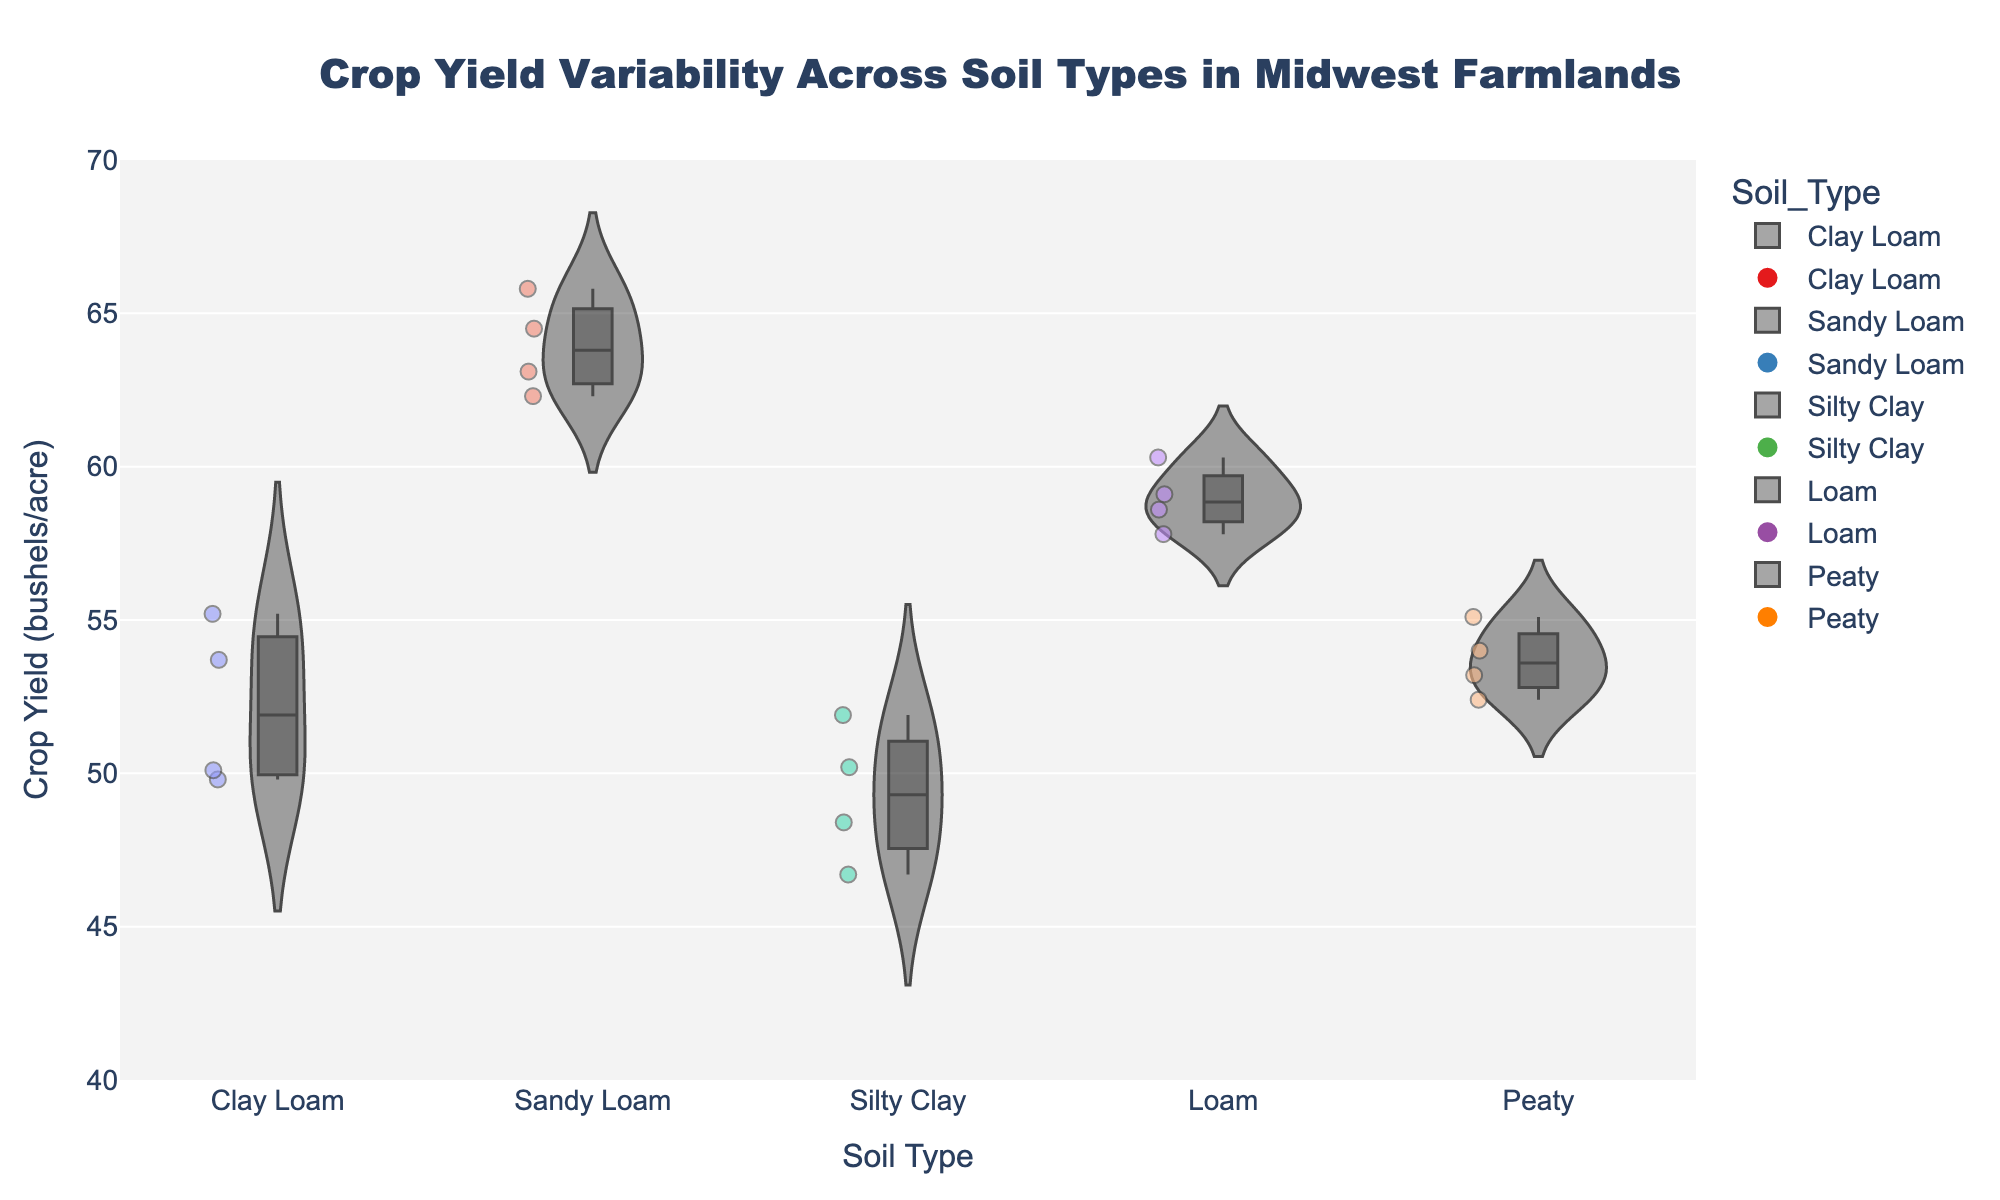What is the average crop yield for Clay Loam soil? To find the average crop yield for Clay Loam soil, sum up the yields for all batches: 55.2, 50.1, 53.7, and 49.8. The total is 208.8. Divide by 4 (the number of points) to get the average yield: 208.8 / 4 = 52.2.
Answer: 52.2 Which soil type has the highest median crop yield? The median is the middle value of a data set when ordered. For Sandy Loam (62.3, 63.1, 64.5, 65.8), the median is between 63.1 and 64.5. Clay Loam (49.8, 50.1, 53.7, 55.2), the median is between 50.1 and 53.7. Silty Clay (46.7, 48.4, 50.2, 51.9), the median is between 48.4 and 50.2. Loam (57.8, 58.6, 59.1, 60.3), the median is between 58.6 and 59.1. Peaty (52.4, 53.2, 54.0, 55.1), the median is between 53.2 and 54.0. Sandy Loam has the highest median.
Answer: Sandy Loam What is the range of crop yields for Silty Clay soil? To find the range, subtract the smallest value from the largest value in the dataset for Silty Clay soil. The smallest value is 46.7, and the largest value is 51.9. The range is 51.9 - 46.7 = 5.2.
Answer: 5.2 Which soil type shows the most variability in crop yield? Variability can be assessed by the spread of the data points in the violin plot. By observing the plot, Sandy Loam appears to have the largest spread or variability, visually displaying a wider range of crop yields compared to other soil types.
Answer: Sandy Loam Are any soil types showing outliers in crop yield? Outliers are data points that appear significantly different from the others. Review the jittered points for any that fall outside the general range. Silty Clay and Clay Loam do not exhibit outliers. Loam, Sandy Loam, and Peaty also do not show distinct outliers within their data points.
Answer: No Which soil type has the smallest interquartile range (IQR) for crop yield? The interquartile range (IQR) is the difference between the first and third quartiles (Q3 - Q1) and is represented by the box in the boxplot included in the violin plot. By inspecting the plot, Peaty seems to have the smallest IQR as its box is the most compact compared to others.
Answer: Peaty How many data points are there for Loam soil? Count the individual jittered points for Loam soil on the violin plot. Loam has four data points.
Answer: 4 What is the crop yield for the highest-performing data point in Sandy Loam soil? Identify the topmost point in the Sandy Loam violin plot, which is the highest point at approximately 65.8 bushels/acre.
Answer: 65.8 